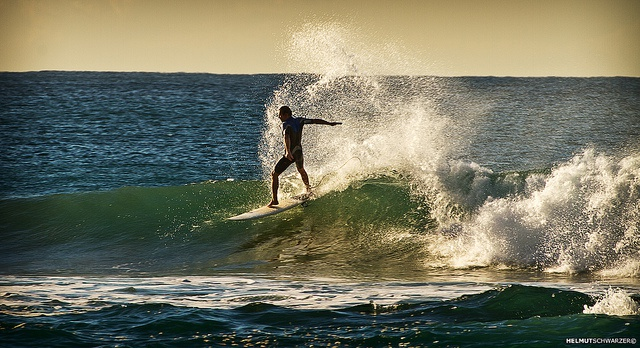Describe the objects in this image and their specific colors. I can see people in olive, black, maroon, tan, and beige tones and surfboard in olive, tan, black, and gray tones in this image. 